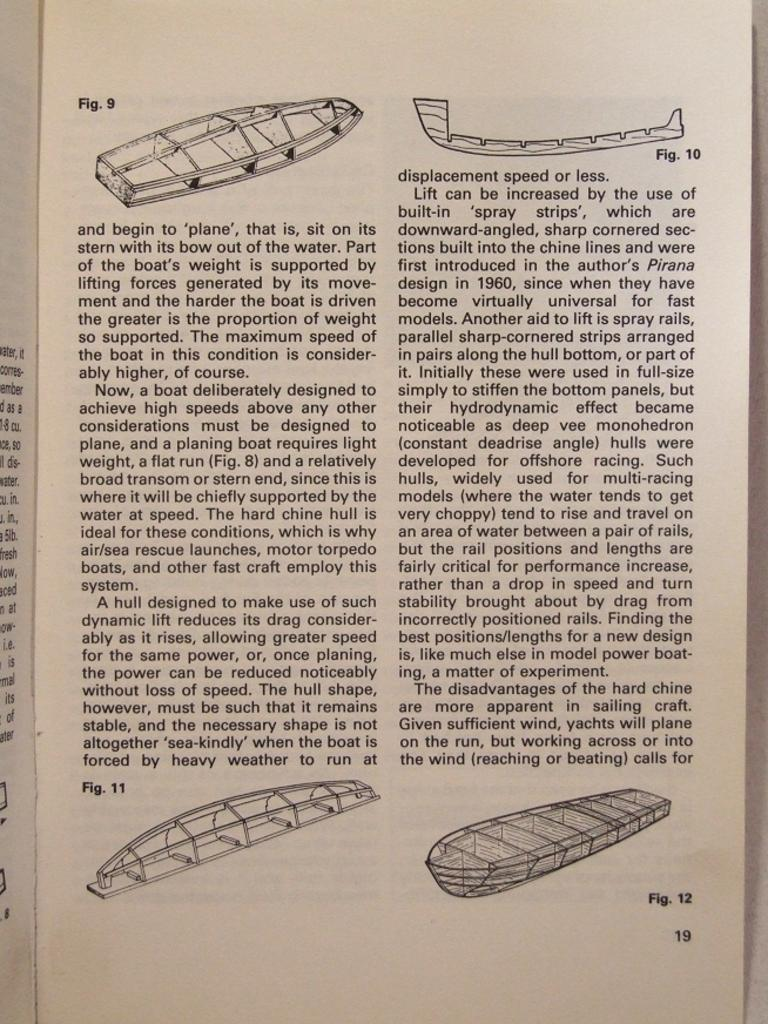What is the main subject of the paper in the image? The paper contains a depiction of boats. Are there any other elements on the paper besides the boats? Yes, there is text on the paper. What type of marble is used to decorate the boats in the image? There is no marble present in the image; it features a paper with a depiction of boats and text. 